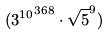Convert formula to latex. <formula><loc_0><loc_0><loc_500><loc_500>( { 3 ^ { 1 0 } } ^ { 3 6 8 } \cdot \sqrt { 5 } ^ { 9 } )</formula> 